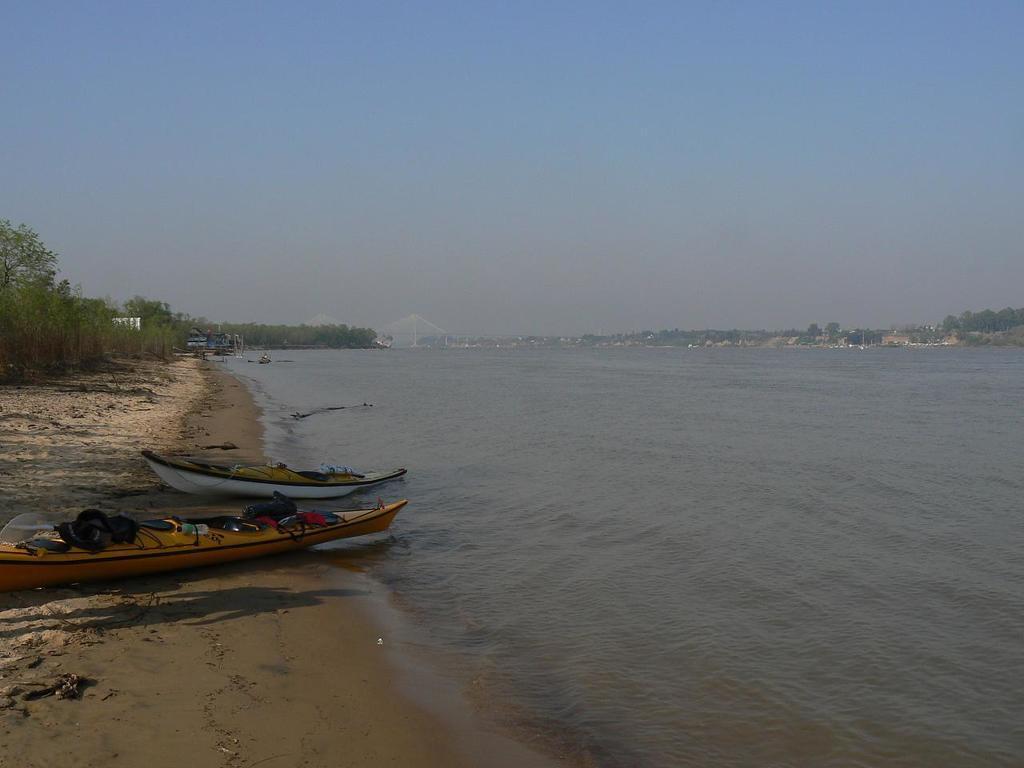Describe this image in one or two sentences. In this picture there are two boats and few trees in the left corner and there is water beside it and there are trees in the background. 